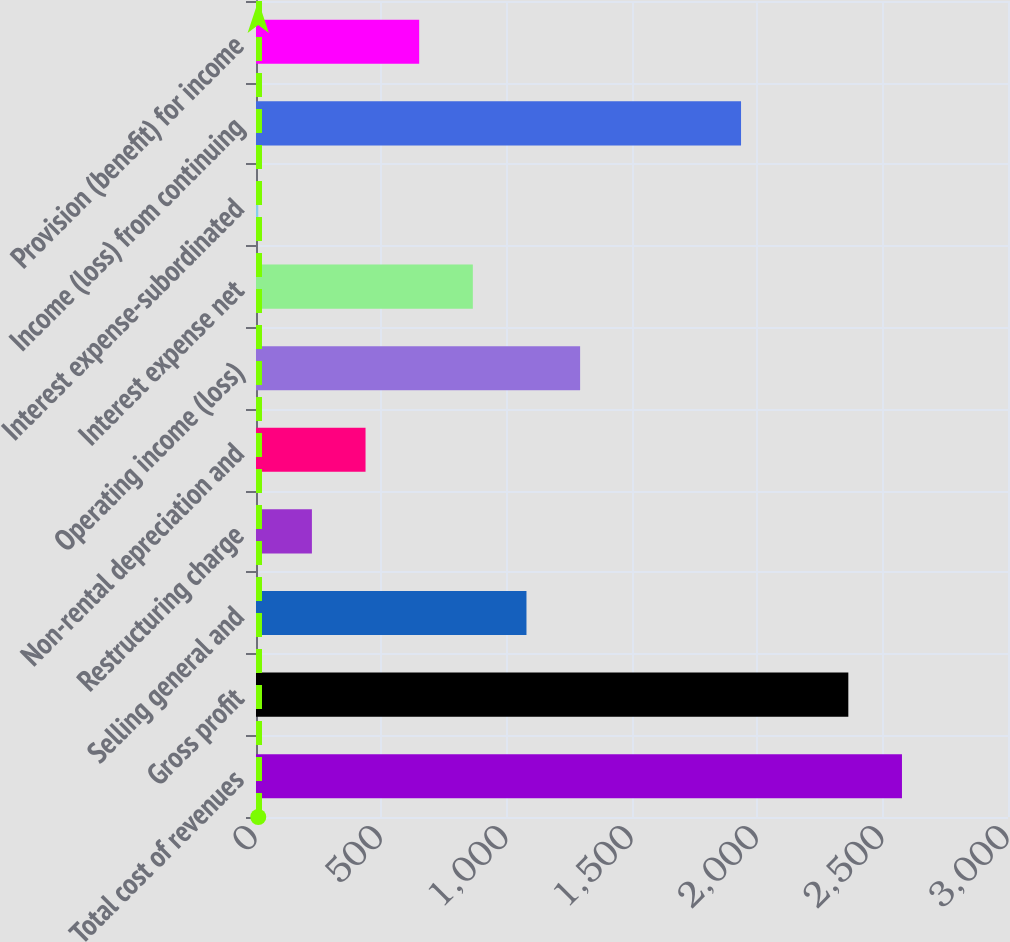<chart> <loc_0><loc_0><loc_500><loc_500><bar_chart><fcel>Total cost of revenues<fcel>Gross profit<fcel>Selling general and<fcel>Restructuring charge<fcel>Non-rental depreciation and<fcel>Operating income (loss)<fcel>Interest expense net<fcel>Interest expense-subordinated<fcel>Income (loss) from continuing<fcel>Provision (benefit) for income<nl><fcel>2577<fcel>2363<fcel>1079<fcel>223<fcel>437<fcel>1293<fcel>865<fcel>9<fcel>1935<fcel>651<nl></chart> 